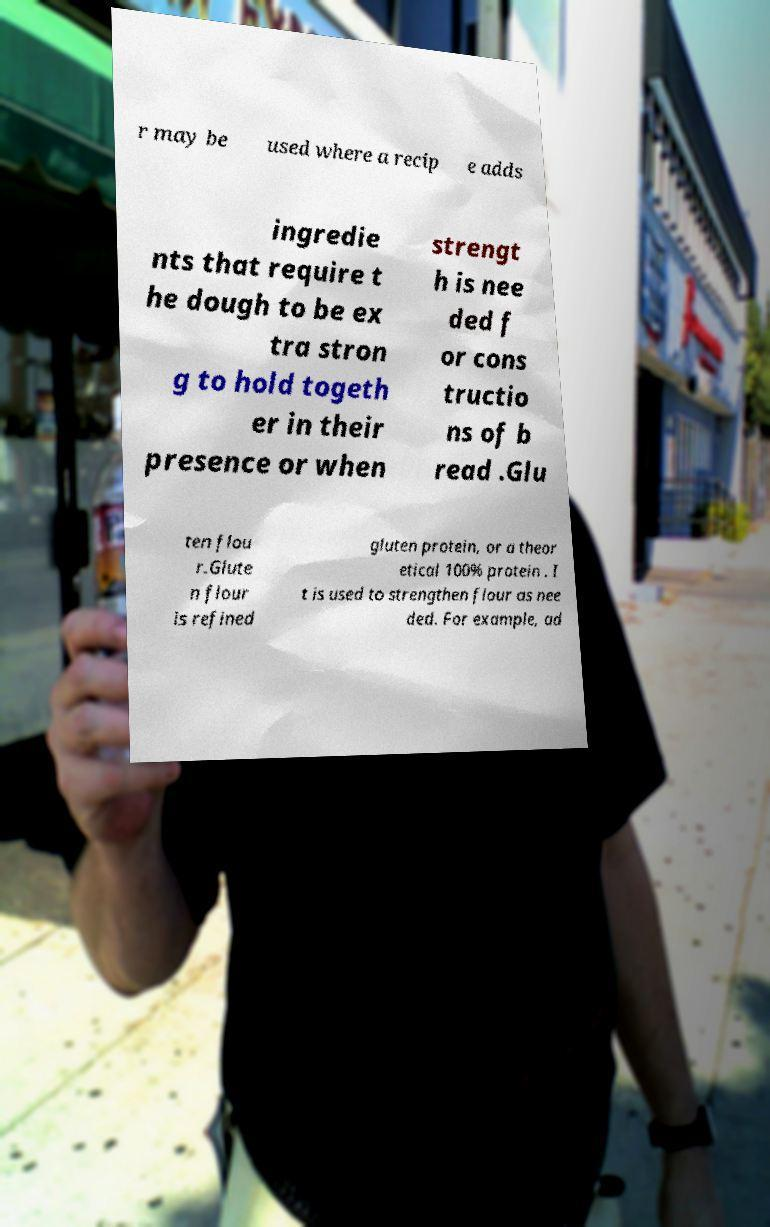I need the written content from this picture converted into text. Can you do that? r may be used where a recip e adds ingredie nts that require t he dough to be ex tra stron g to hold togeth er in their presence or when strengt h is nee ded f or cons tructio ns of b read .Glu ten flou r.Glute n flour is refined gluten protein, or a theor etical 100% protein . I t is used to strengthen flour as nee ded. For example, ad 